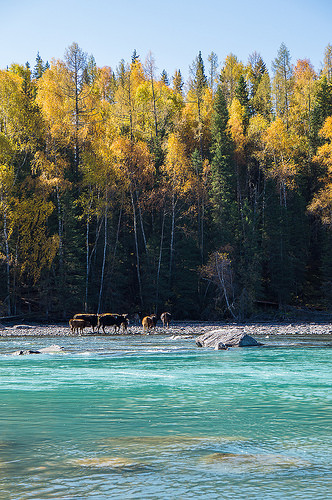<image>
Can you confirm if the animals is behind the trees? No. The animals is not behind the trees. From this viewpoint, the animals appears to be positioned elsewhere in the scene. Is the animal next to the river? Yes. The animal is positioned adjacent to the river, located nearby in the same general area. 